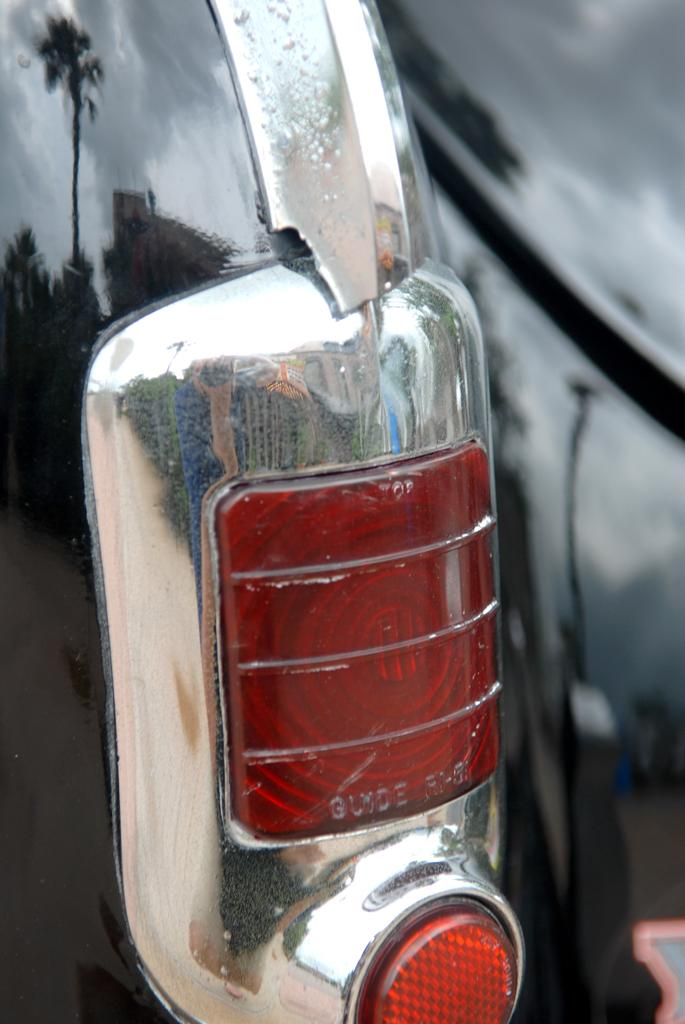What is the main subject of the image? There is a vehicle in the image. Can you describe any specific features of the vehicle? The tail light of the vehicle is visible. How many servant statues are present in the image? There are no servant statues present in the image; it features a vehicle with a visible tail light. What type of parcel can be seen being delivered by the ladybug in the image? There is no parcel or ladybug present in the image. 